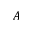Convert formula to latex. <formula><loc_0><loc_0><loc_500><loc_500>A</formula> 